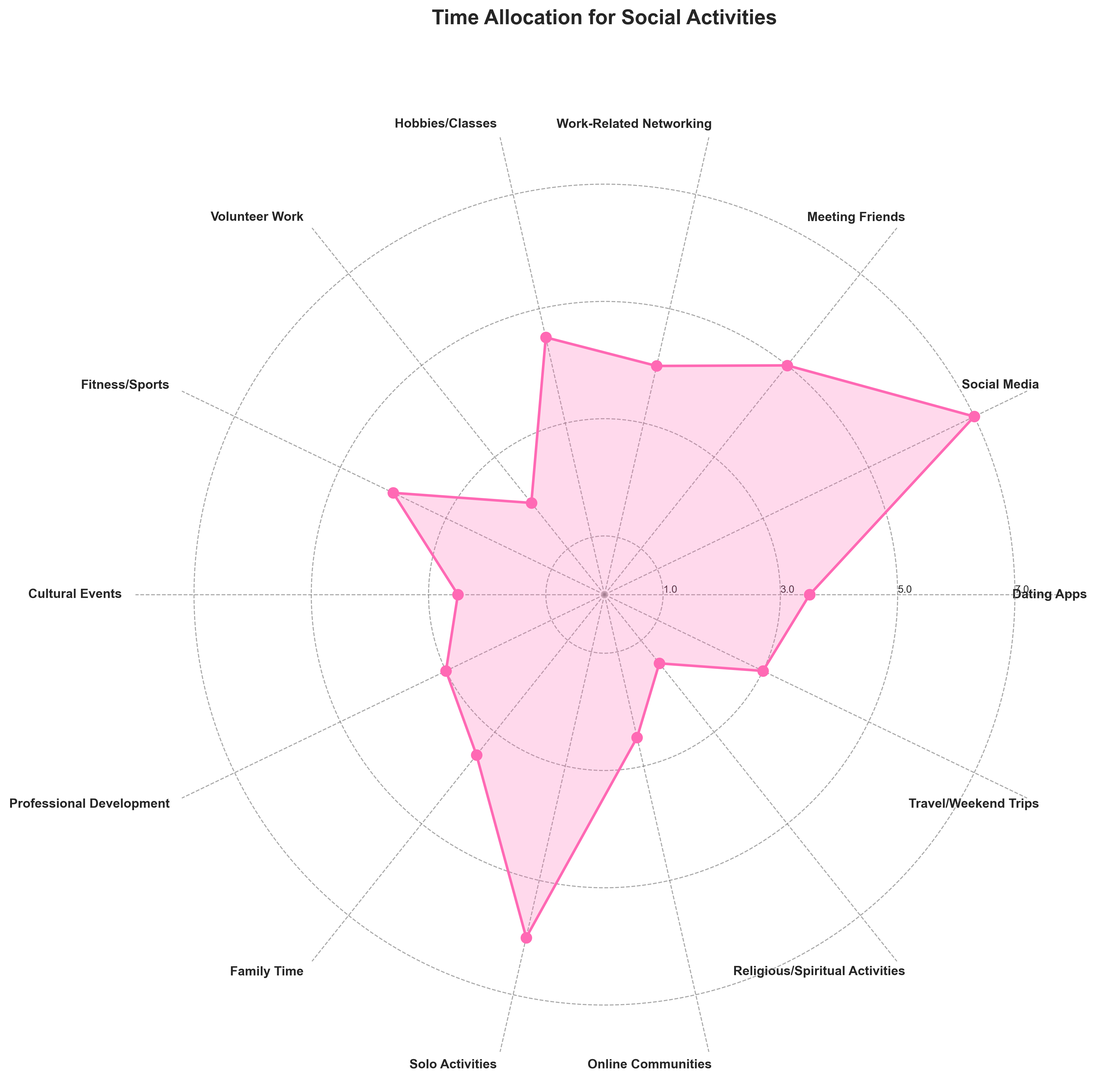Which social activity do single professionals spend the most time on? Observe the longest plot segment. The activity with the largest segment is Social Media, which lies at the highest radial distance.
Answer: Social Media Which activities have equal time allocation? Look for activities with plot points at the same radial distance. Dating Apps and Family Time both have plot points at a radial distance of 3.5, and Cultural Events and Online Communities both have plot points at 2.5.
Answer: Dating Apps and Family Time; Cultural Events and Online Communities How much time is spent on physical fitness compared to volunteer work? Compare the lengths of the segments for Fitness/Sports and Volunteer Work. Fitness/Sports is at 4, while Volunteer Work is at 2, making Fitness/Sports twice as long.
Answer: 4 hours on Fitness/Sports, 2 hours on Volunteer Work How does time spent on hobbies compare to time spent on professional development? Locate the plot segments for Hobbies/Classes and Professional Development. Hobbies/Classes are at 4.5, while Professional Development is at 3.
Answer: 4.5 hours on Hobbies/Classes, 3 hours on Professional Development What is the total time spent on activities with less than 3 hours per week? Identify activities with radial distances less than 3: Volunteer Work (2), Cultural Events (2.5), Online Communities (2.5), and Religious/Spiritual Activities (1.5). Sum these values: 2 + 2.5 + 2.5 + 1.5.
Answer: 8.5 hours How do solo activities compare to family time? Compare the radial distances for Solo Activities and Family Time. Solo Activities are at 6, while Family Time is at 3.5.
Answer: 6 hours on Solo Activities, 3.5 hours on Family Time What's the difference in time spent between online communities and travel? Look at the segments for Online Communities and Travel/Weekend Trips. Travel/Weekend Trips is at 3, while Online Communities is at 2.5. Subtract 2.5 from 3.
Answer: 0.5 hours more on Travel/Weekend Trips What's the average time spent on activities related to personal growth (fitness/sports, hobbies/classes, professional development)? The segments for Fitness/Sports, Hobbies/Classes, and Professional Development are at 4, 4.5, and 3 respectively. Sum these values: 4 + 4.5 + 3, then divide by 3.
Answer: 3.83 hours Among work-related networking, dating apps, and religious activities, which has the smallest time allocation? Compare the radial distances for Work-Related Networking, Dating Apps, and Religious/Spiritual Activities. Religious/Spiritual Activities have the smallest distance at 1.5.
Answer: Religious/Spiritual Activities 